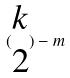<formula> <loc_0><loc_0><loc_500><loc_500>( \begin{matrix} k \\ 2 \end{matrix} ) - m</formula> 